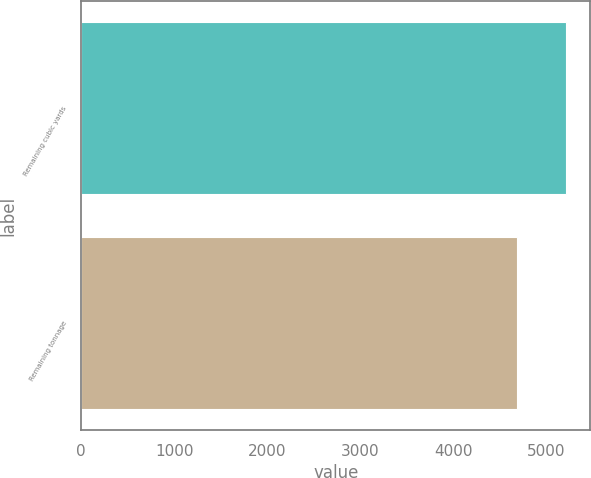Convert chart to OTSL. <chart><loc_0><loc_0><loc_500><loc_500><bar_chart><fcel>Remaining cubic yards<fcel>Remaining tonnage<nl><fcel>5209<fcel>4680<nl></chart> 